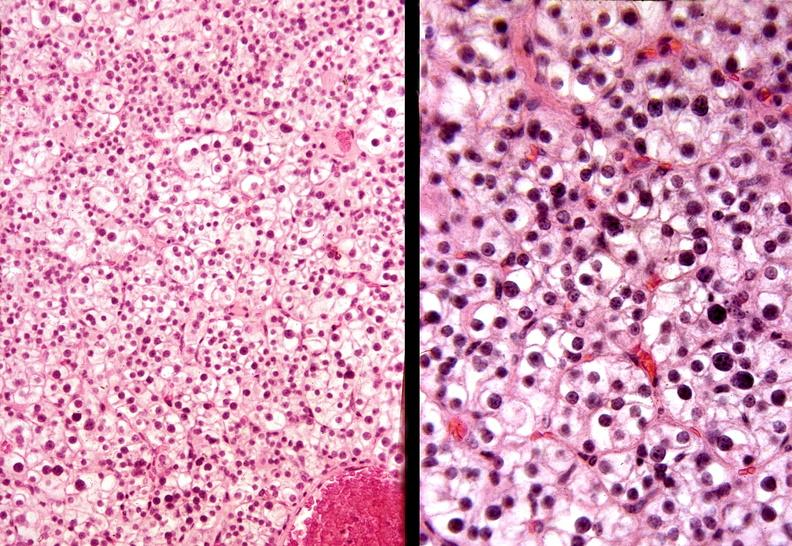where is this part in the figure?
Answer the question using a single word or phrase. Endocrine system 